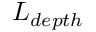<formula> <loc_0><loc_0><loc_500><loc_500>L _ { d e p t h }</formula> 